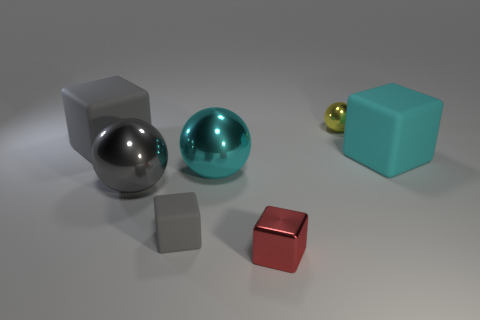Subtract all cyan cylinders. How many gray cubes are left? 2 Subtract all rubber cubes. How many cubes are left? 1 Subtract all red blocks. How many blocks are left? 3 Add 2 tiny green shiny objects. How many objects exist? 9 Subtract all spheres. How many objects are left? 4 Subtract all green cubes. Subtract all gray cylinders. How many cubes are left? 4 Add 4 metallic blocks. How many metallic blocks are left? 5 Add 6 big purple rubber spheres. How many big purple rubber spheres exist? 6 Subtract 0 red cylinders. How many objects are left? 7 Subtract all big gray shiny spheres. Subtract all cyan shiny things. How many objects are left? 5 